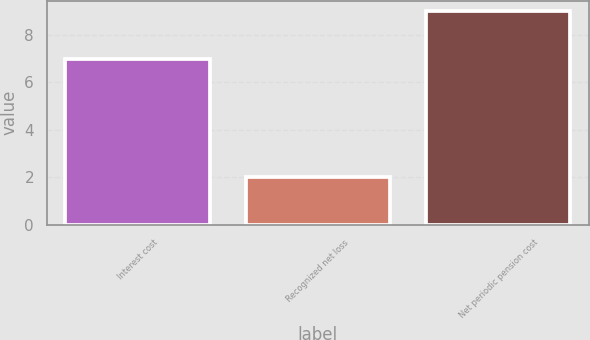Convert chart to OTSL. <chart><loc_0><loc_0><loc_500><loc_500><bar_chart><fcel>Interest cost<fcel>Recognized net loss<fcel>Net periodic pension cost<nl><fcel>7<fcel>2<fcel>9<nl></chart> 